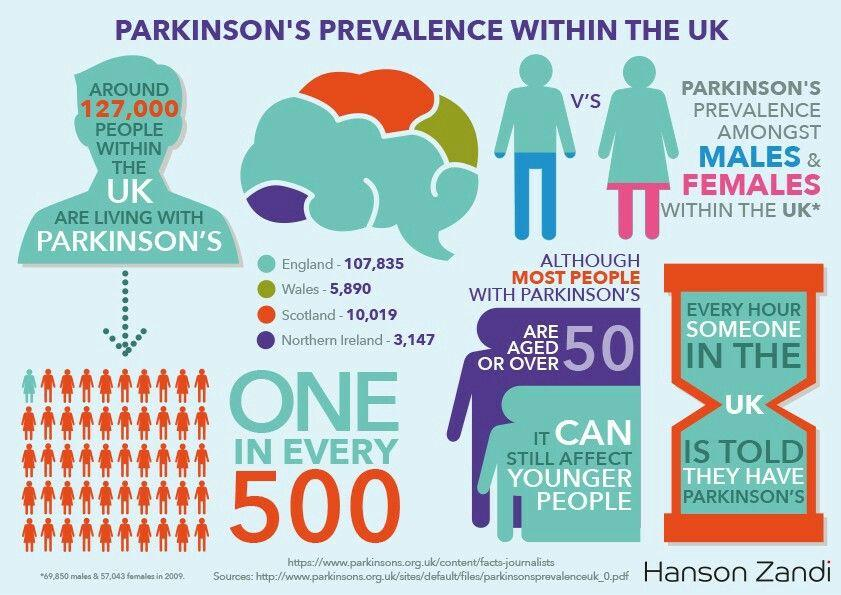Identify some key points in this picture. It is estimated that approximately 1 in every 500 individuals in the United Kingdom is affected by Parkinson's disease, a progressive neurological disorder characterized by motor symptoms such as tremors, stiffness, and difficulty with movement. Scotland has the second highest number of people affected by Parkinson's disease in the United Kingdom. In the information graphic, 4 countries are listed and their prevalence of Parkinson's disease is provided. Parkinson's disease is more commonly found in males than in females. Wales has the third highest number of people affected by Parkinson's disease in the United Kingdom. 